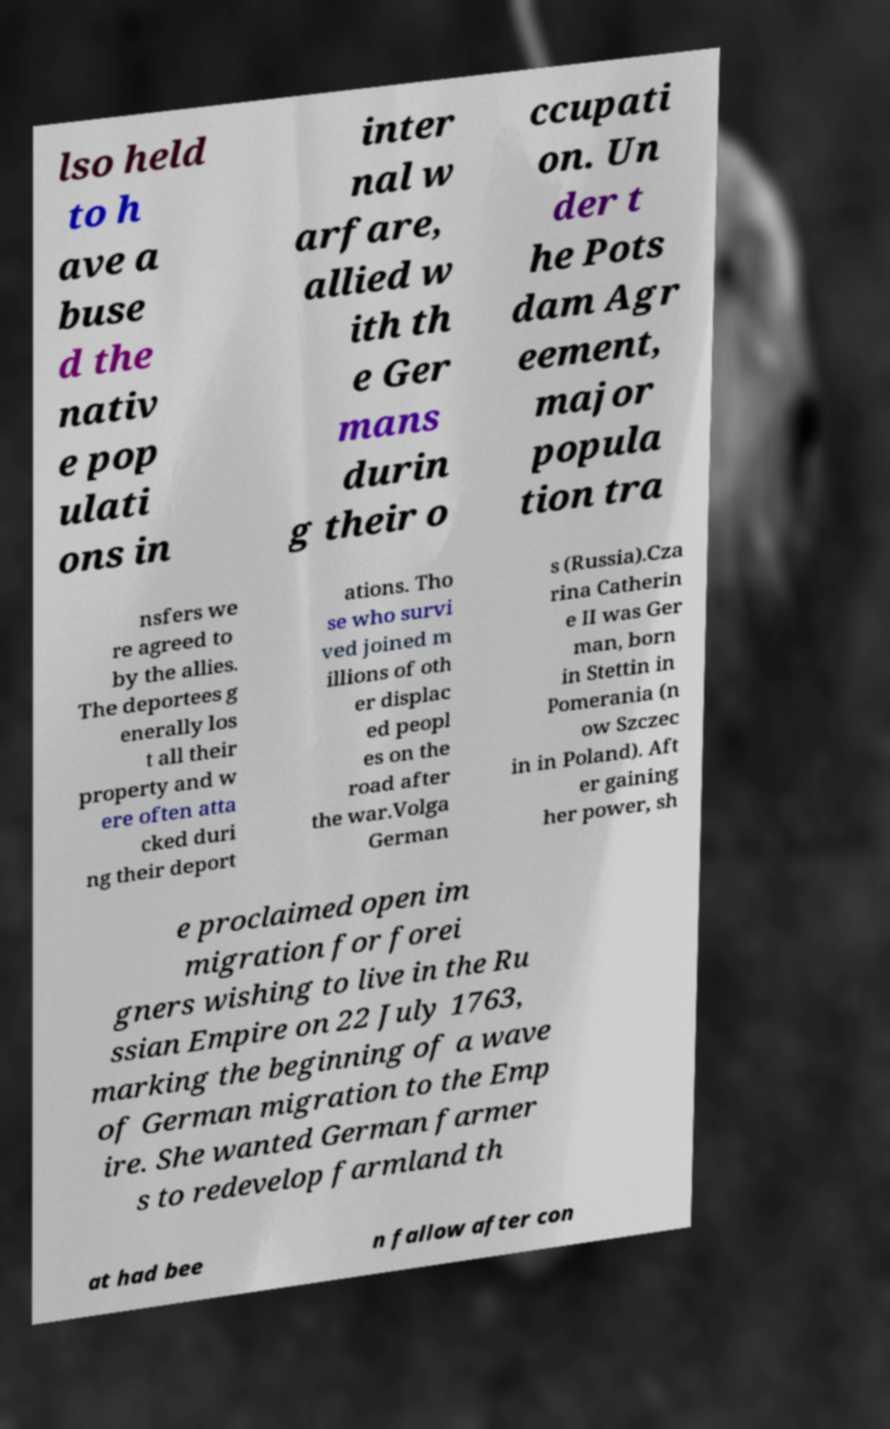Could you assist in decoding the text presented in this image and type it out clearly? lso held to h ave a buse d the nativ e pop ulati ons in inter nal w arfare, allied w ith th e Ger mans durin g their o ccupati on. Un der t he Pots dam Agr eement, major popula tion tra nsfers we re agreed to by the allies. The deportees g enerally los t all their property and w ere often atta cked duri ng their deport ations. Tho se who survi ved joined m illions of oth er displac ed peopl es on the road after the war.Volga German s (Russia).Cza rina Catherin e II was Ger man, born in Stettin in Pomerania (n ow Szczec in in Poland). Aft er gaining her power, sh e proclaimed open im migration for forei gners wishing to live in the Ru ssian Empire on 22 July 1763, marking the beginning of a wave of German migration to the Emp ire. She wanted German farmer s to redevelop farmland th at had bee n fallow after con 